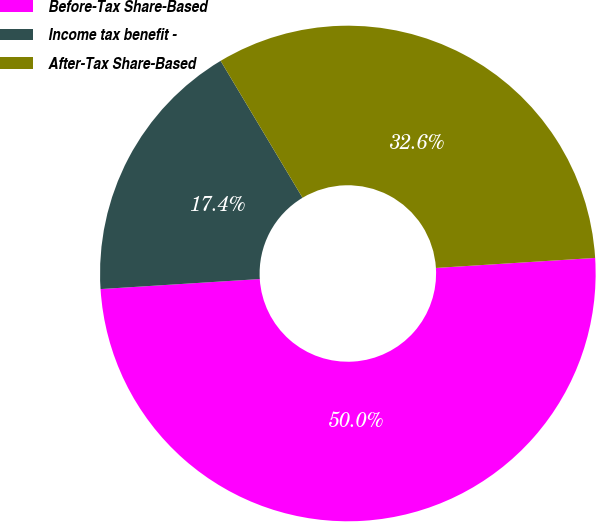Convert chart. <chart><loc_0><loc_0><loc_500><loc_500><pie_chart><fcel>Before-Tax Share-Based<fcel>Income tax benefit -<fcel>After-Tax Share-Based<nl><fcel>50.0%<fcel>17.42%<fcel>32.58%<nl></chart> 